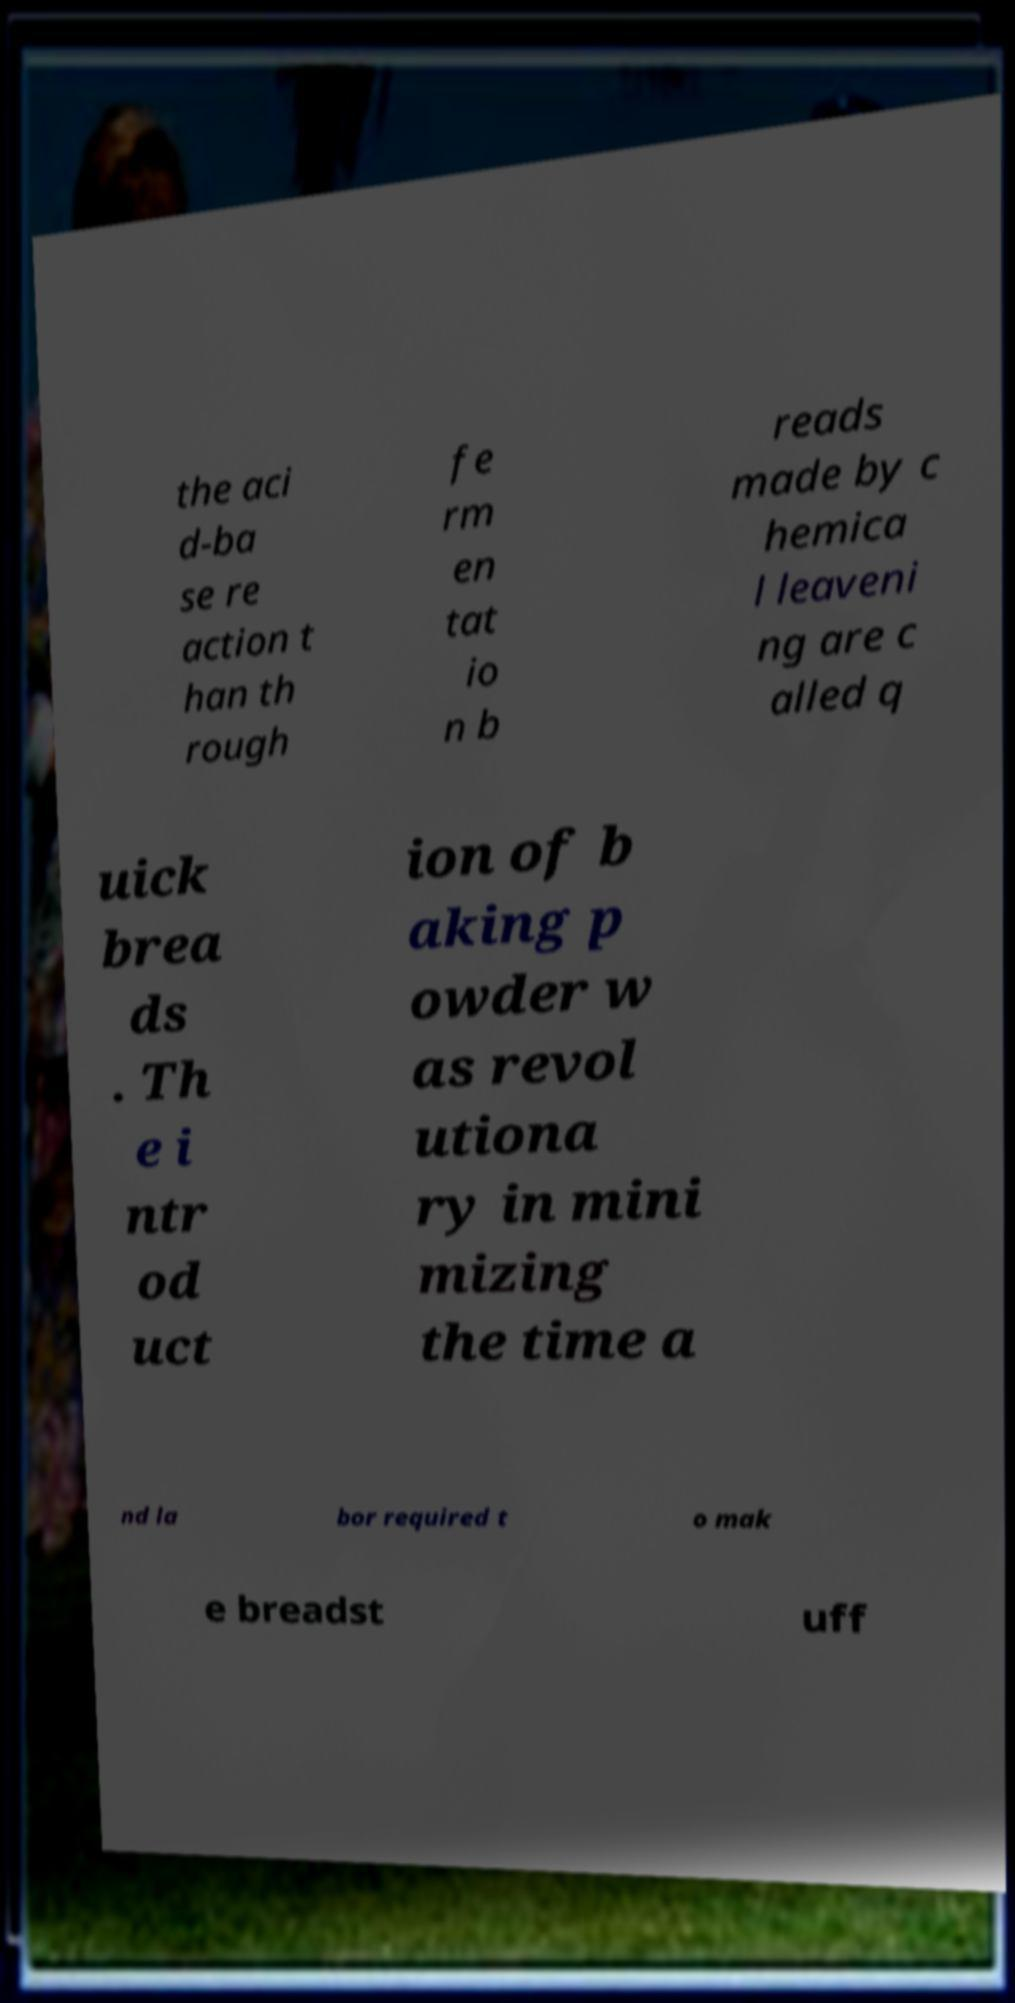Can you read and provide the text displayed in the image?This photo seems to have some interesting text. Can you extract and type it out for me? the aci d-ba se re action t han th rough fe rm en tat io n b reads made by c hemica l leaveni ng are c alled q uick brea ds . Th e i ntr od uct ion of b aking p owder w as revol utiona ry in mini mizing the time a nd la bor required t o mak e breadst uff 